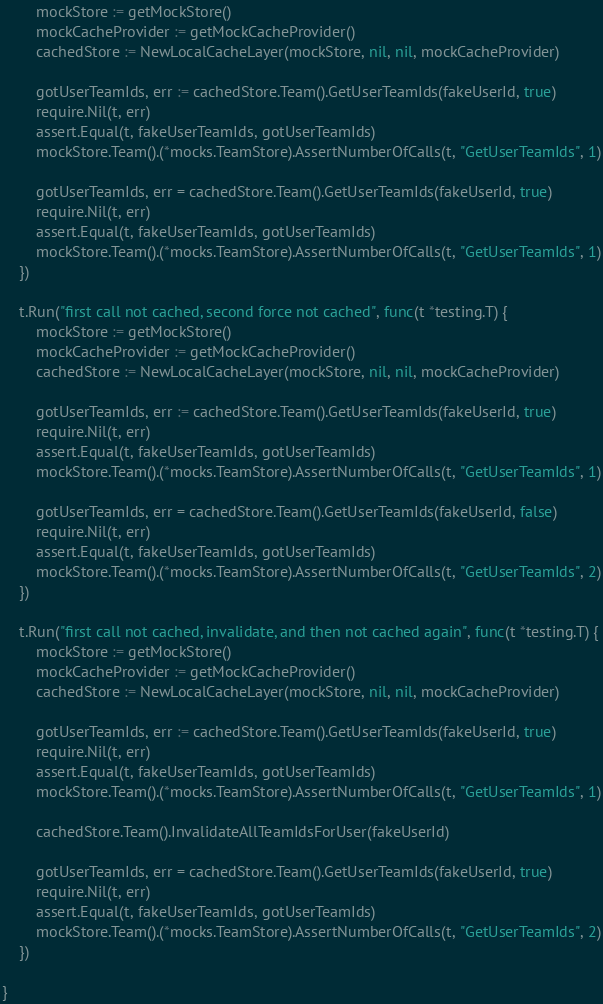<code> <loc_0><loc_0><loc_500><loc_500><_Go_>		mockStore := getMockStore()
		mockCacheProvider := getMockCacheProvider()
		cachedStore := NewLocalCacheLayer(mockStore, nil, nil, mockCacheProvider)

		gotUserTeamIds, err := cachedStore.Team().GetUserTeamIds(fakeUserId, true)
		require.Nil(t, err)
		assert.Equal(t, fakeUserTeamIds, gotUserTeamIds)
		mockStore.Team().(*mocks.TeamStore).AssertNumberOfCalls(t, "GetUserTeamIds", 1)

		gotUserTeamIds, err = cachedStore.Team().GetUserTeamIds(fakeUserId, true)
		require.Nil(t, err)
		assert.Equal(t, fakeUserTeamIds, gotUserTeamIds)
		mockStore.Team().(*mocks.TeamStore).AssertNumberOfCalls(t, "GetUserTeamIds", 1)
	})

	t.Run("first call not cached, second force not cached", func(t *testing.T) {
		mockStore := getMockStore()
		mockCacheProvider := getMockCacheProvider()
		cachedStore := NewLocalCacheLayer(mockStore, nil, nil, mockCacheProvider)

		gotUserTeamIds, err := cachedStore.Team().GetUserTeamIds(fakeUserId, true)
		require.Nil(t, err)
		assert.Equal(t, fakeUserTeamIds, gotUserTeamIds)
		mockStore.Team().(*mocks.TeamStore).AssertNumberOfCalls(t, "GetUserTeamIds", 1)

		gotUserTeamIds, err = cachedStore.Team().GetUserTeamIds(fakeUserId, false)
		require.Nil(t, err)
		assert.Equal(t, fakeUserTeamIds, gotUserTeamIds)
		mockStore.Team().(*mocks.TeamStore).AssertNumberOfCalls(t, "GetUserTeamIds", 2)
	})

	t.Run("first call not cached, invalidate, and then not cached again", func(t *testing.T) {
		mockStore := getMockStore()
		mockCacheProvider := getMockCacheProvider()
		cachedStore := NewLocalCacheLayer(mockStore, nil, nil, mockCacheProvider)

		gotUserTeamIds, err := cachedStore.Team().GetUserTeamIds(fakeUserId, true)
		require.Nil(t, err)
		assert.Equal(t, fakeUserTeamIds, gotUserTeamIds)
		mockStore.Team().(*mocks.TeamStore).AssertNumberOfCalls(t, "GetUserTeamIds", 1)

		cachedStore.Team().InvalidateAllTeamIdsForUser(fakeUserId)

		gotUserTeamIds, err = cachedStore.Team().GetUserTeamIds(fakeUserId, true)
		require.Nil(t, err)
		assert.Equal(t, fakeUserTeamIds, gotUserTeamIds)
		mockStore.Team().(*mocks.TeamStore).AssertNumberOfCalls(t, "GetUserTeamIds", 2)
	})

}
</code> 